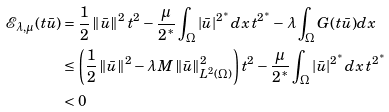<formula> <loc_0><loc_0><loc_500><loc_500>\mathcal { E } _ { \lambda , \mu } ( t \bar { u } ) & = \frac { 1 } { 2 } \left \| \bar { u } \right \| ^ { 2 } t ^ { 2 } - \frac { \mu } { 2 ^ { * } } \int _ { \Omega } | \bar { u } | ^ { 2 ^ { * } } d x \, t ^ { 2 ^ { * } } - \lambda \int _ { \Omega } G ( t \bar { u } ) d x \\ & \leq \left ( \frac { 1 } { 2 } \left \| \bar { u } \right \| ^ { 2 } - \lambda M \left \| \bar { u } \right \| ^ { 2 } _ { L ^ { 2 } ( \Omega ) } \right ) t ^ { 2 } - \frac { \mu } { 2 ^ { * } } \int _ { \Omega } | \bar { u } | ^ { 2 ^ { * } } d x \, t ^ { 2 ^ { * } } \\ & < 0</formula> 